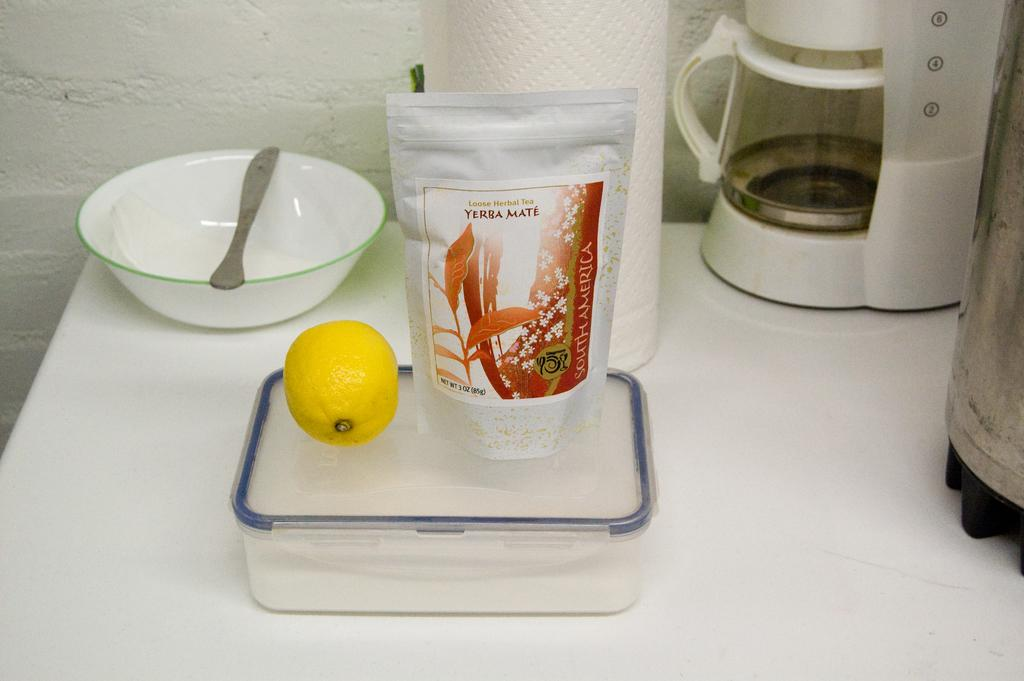Provide a one-sentence caption for the provided image. Near a coffee maker a lemon is placed on a plastic container next to a bag of herbal tea. 